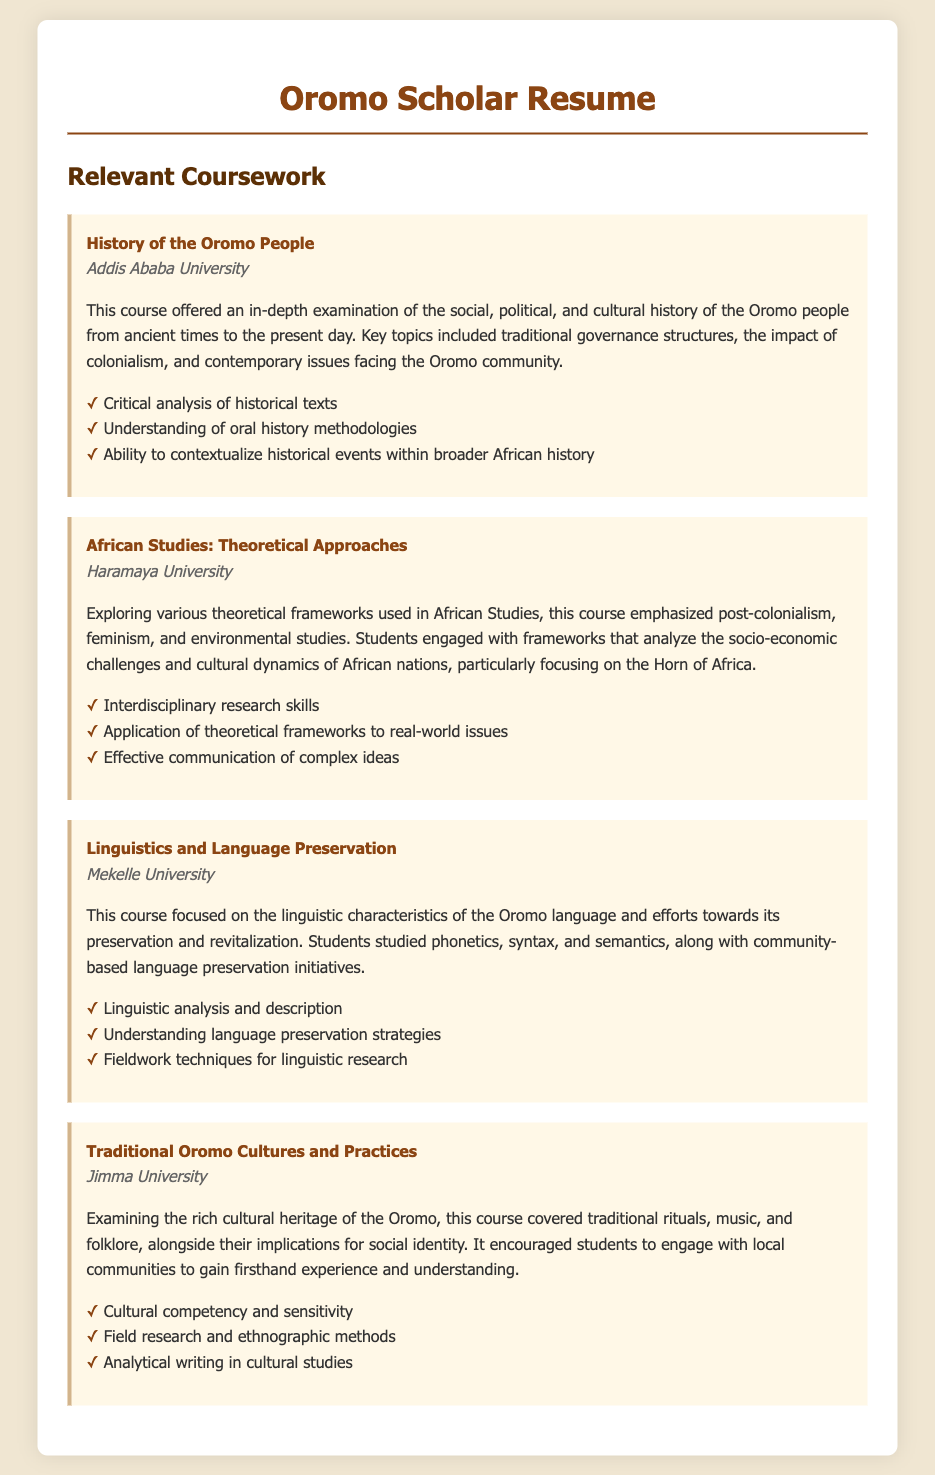What is the title of the course about the Oromo people's history? The title of the course is explicitly mentioned in the document as "History of the Oromo People."
Answer: History of the Oromo People Which university offered the African Studies course? The document states that "Haramaya University" offered the course on African Studies.
Answer: Haramaya University What key topic is covered in the "Linguistics and Language Preservation" course? The document mentions that the course focuses on "linguistic characteristics of the Oromo language."
Answer: Linguistic characteristics of the Oromo language How many skills are listed under the "Traditional Oromo Cultures and Practices" course? The skills listed in the document can be counted, which shows that there are three skills.
Answer: 3 What type of analysis is emphasized in the "History of the Oromo People" course? The course emphasizes "critical analysis of historical texts," as mentioned in the document.
Answer: Critical analysis of historical texts Which theoretical frameworks are primarily discussed in the African Studies course? The document specifically mentions "post-colonialism, feminism, and environmental studies" as the theoretical frameworks discussed.
Answer: Post-colonialism, feminism, and environmental studies Which university provided the course on Linguistics and Language Preservation? The provided information states that "Mekelle University" taught the course.
Answer: Mekelle University What is a key skill acquired from the course on Traditional Oromo Cultures? The document notes that "cultural competency and sensitivity" is a key skill acquired from this course.
Answer: Cultural competency and sensitivity 